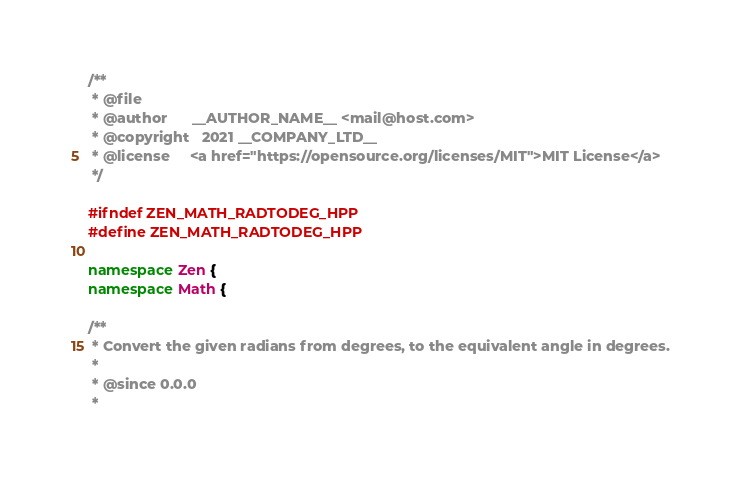Convert code to text. <code><loc_0><loc_0><loc_500><loc_500><_C++_>/**
 * @file
 * @author		__AUTHOR_NAME__ <mail@host.com>
 * @copyright	2021 __COMPANY_LTD__
 * @license		<a href="https://opensource.org/licenses/MIT">MIT License</a>
 */

#ifndef ZEN_MATH_RADTODEG_HPP
#define ZEN_MATH_RADTODEG_HPP

namespace Zen {
namespace Math {

/**
 * Convert the given radians from degrees, to the equivalent angle in degrees.
 *
 * @since 0.0.0
 *</code> 